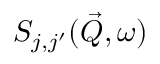<formula> <loc_0><loc_0><loc_500><loc_500>S _ { j , j ^ { \prime } } ( \vec { Q } , \omega )</formula> 